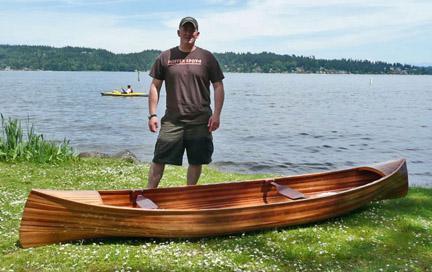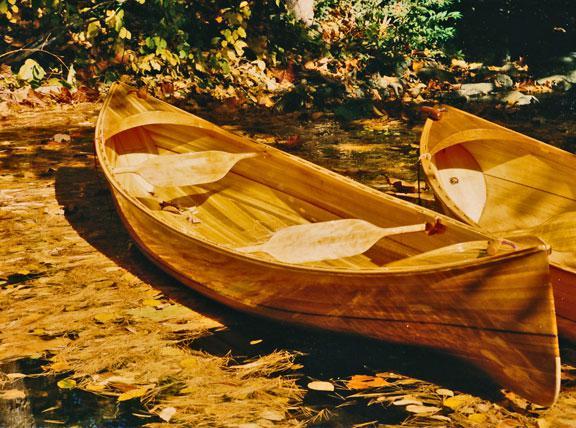The first image is the image on the left, the second image is the image on the right. Considering the images on both sides, is "Two boats sit on the land in the image on the right." valid? Answer yes or no. Yes. The first image is the image on the left, the second image is the image on the right. For the images displayed, is the sentence "One canoe is near water." factually correct? Answer yes or no. Yes. 